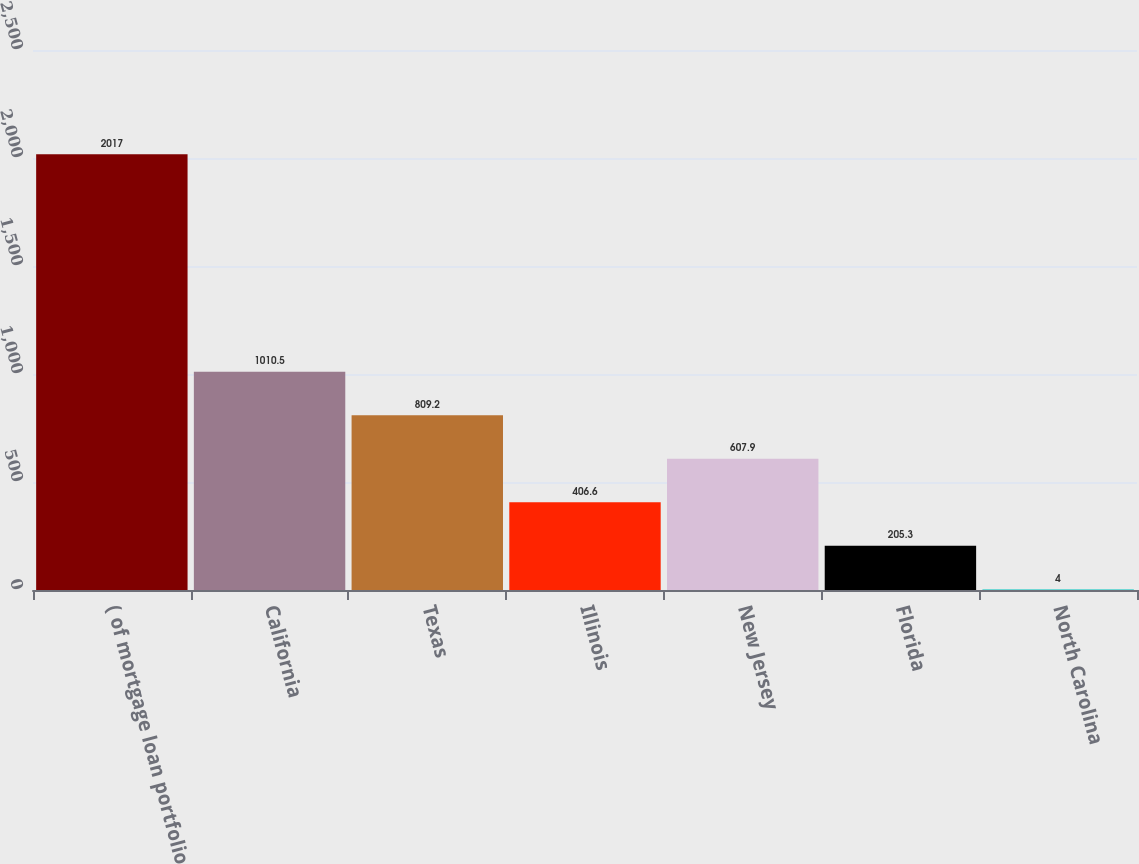<chart> <loc_0><loc_0><loc_500><loc_500><bar_chart><fcel>( of mortgage loan portfolio<fcel>California<fcel>Texas<fcel>Illinois<fcel>New Jersey<fcel>Florida<fcel>North Carolina<nl><fcel>2017<fcel>1010.5<fcel>809.2<fcel>406.6<fcel>607.9<fcel>205.3<fcel>4<nl></chart> 